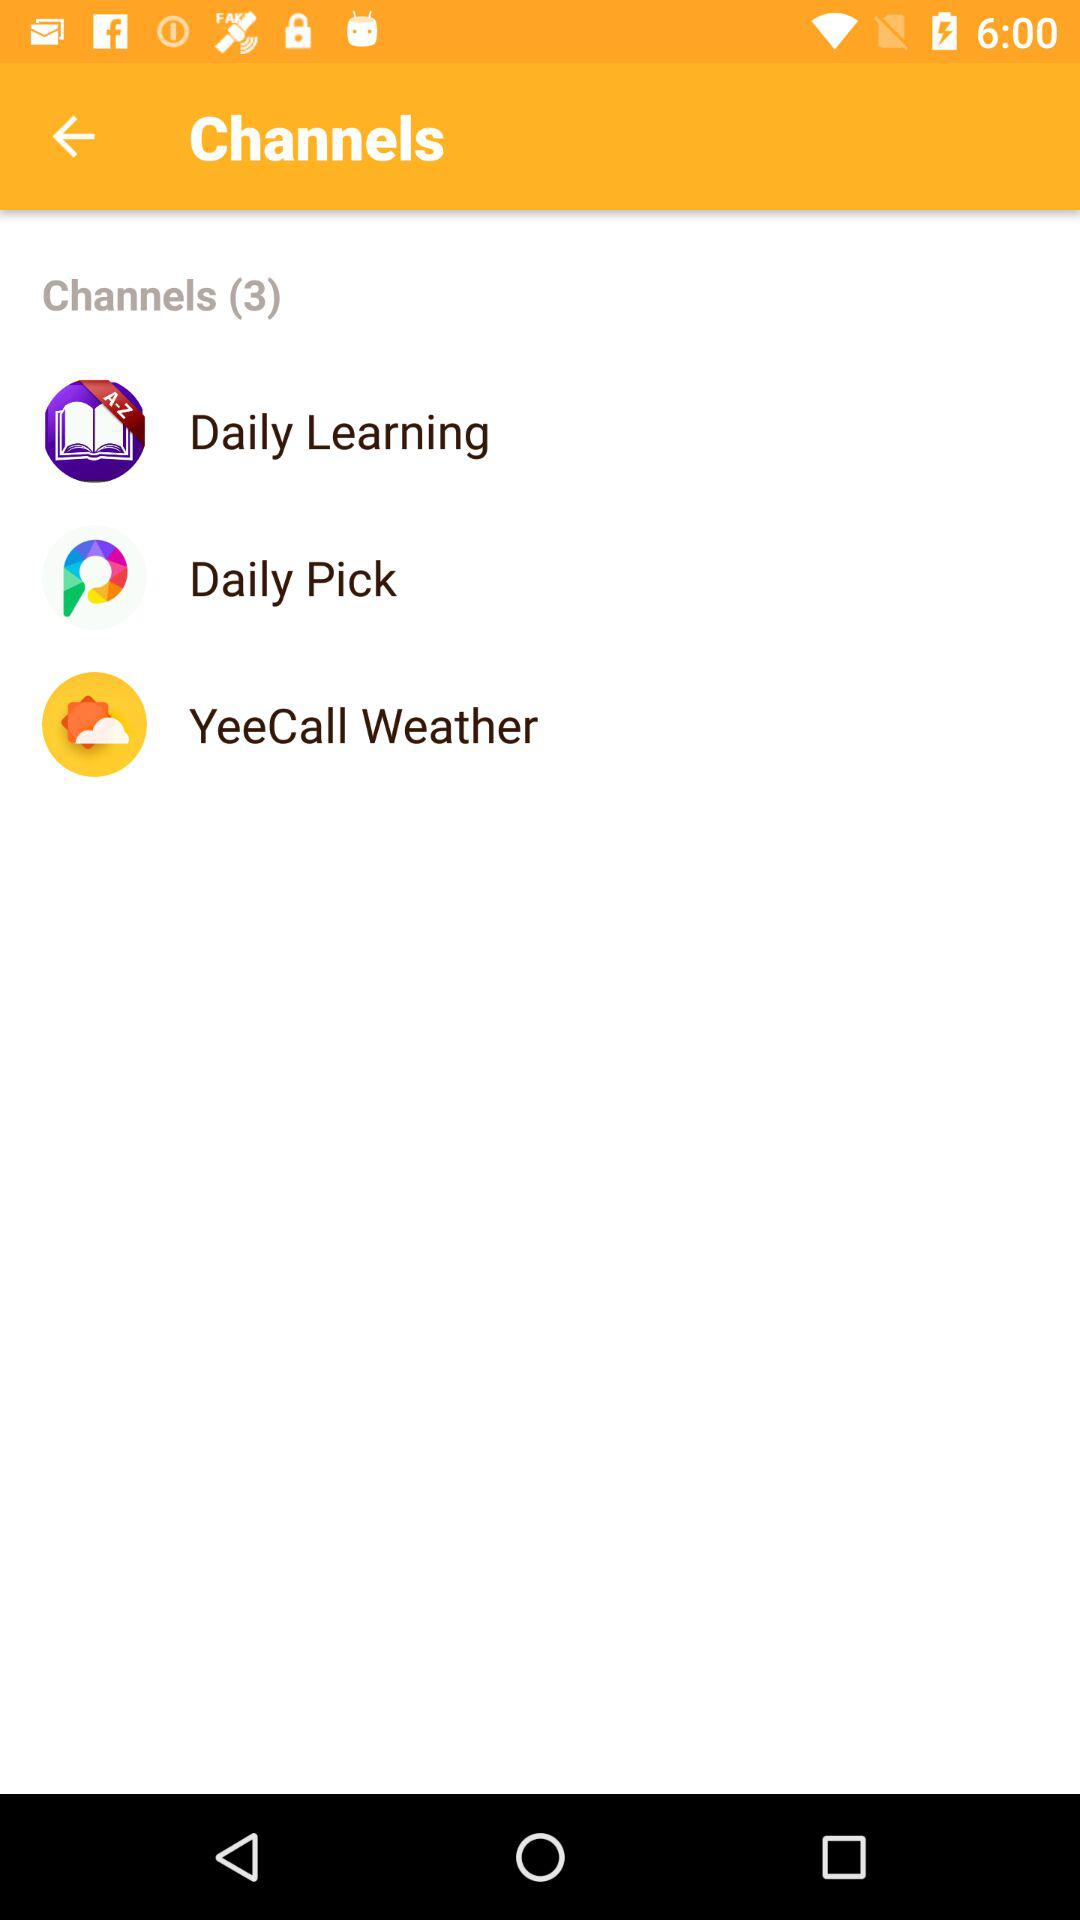How many channels are there? There are 3 channels. 